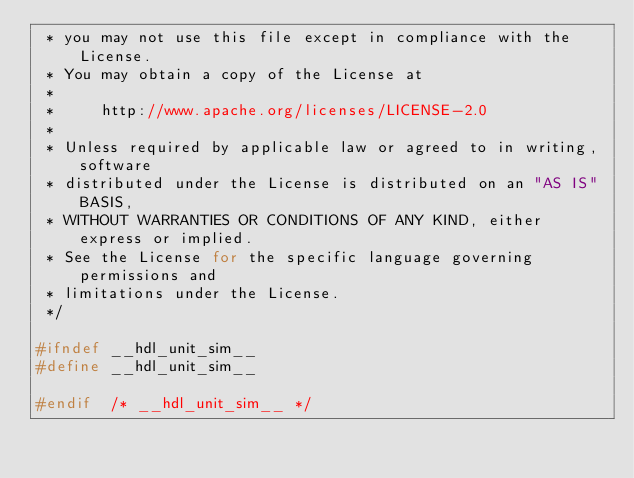<code> <loc_0><loc_0><loc_500><loc_500><_C_> * you may not use this file except in compliance with the License.
 * You may obtain a copy of the License at
 *
 *     http://www.apache.org/licenses/LICENSE-2.0
 *
 * Unless required by applicable law or agreed to in writing, software
 * distributed under the License is distributed on an "AS IS" BASIS,
 * WITHOUT WARRANTIES OR CONDITIONS OF ANY KIND, either express or implied.
 * See the License for the specific language governing permissions and
 * limitations under the License.
 */

#ifndef __hdl_unit_sim__
#define __hdl_unit_sim__

#endif	/* __hdl_unit_sim__ */
</code> 